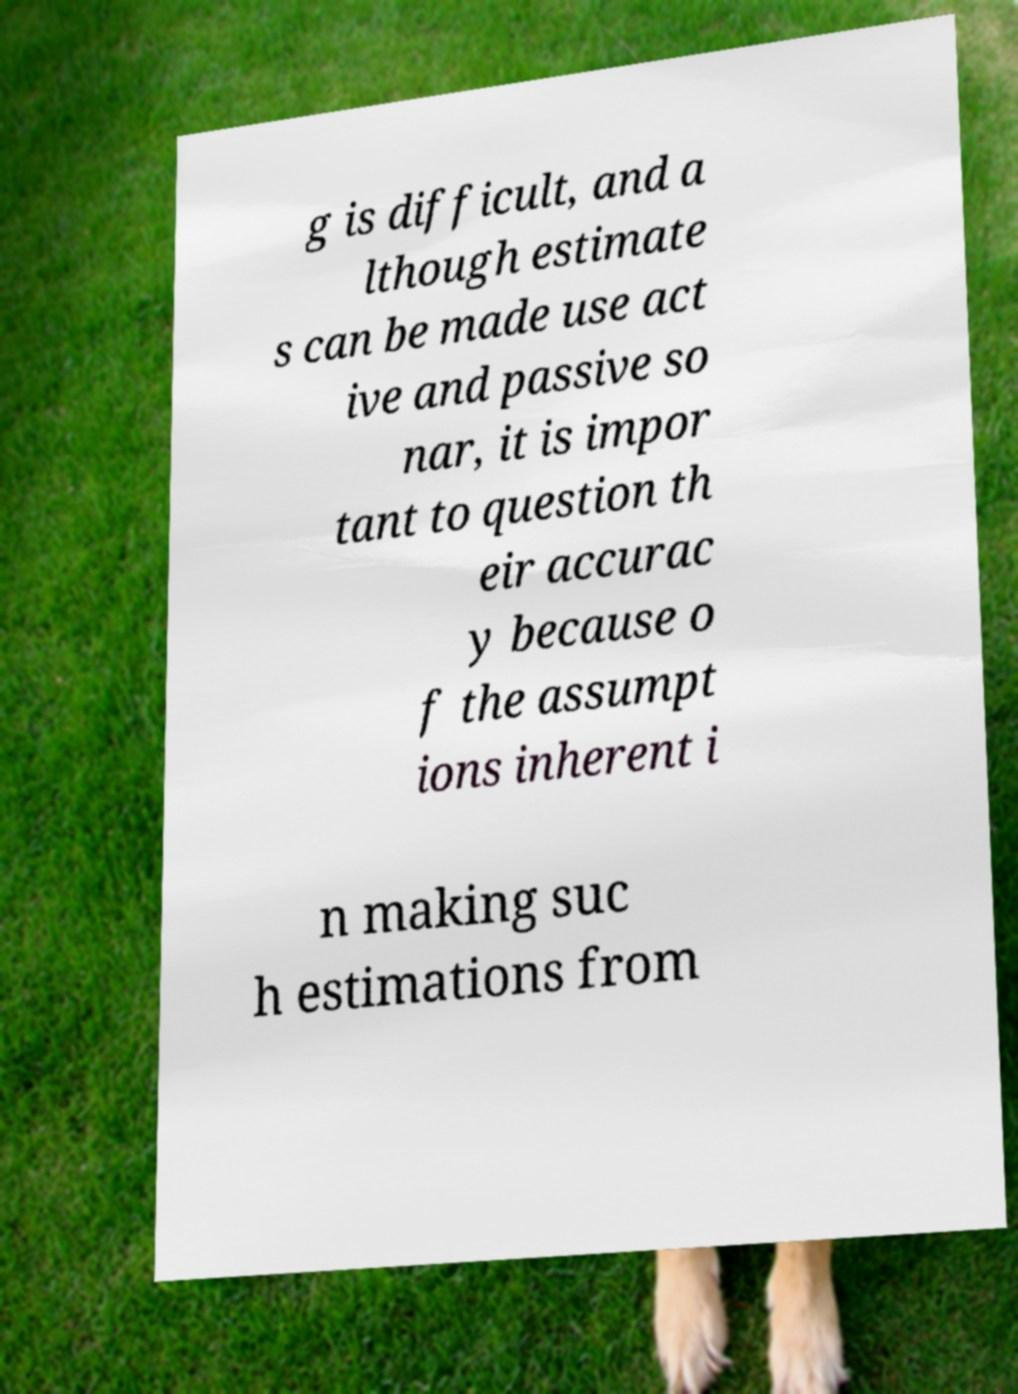Please read and relay the text visible in this image. What does it say? g is difficult, and a lthough estimate s can be made use act ive and passive so nar, it is impor tant to question th eir accurac y because o f the assumpt ions inherent i n making suc h estimations from 